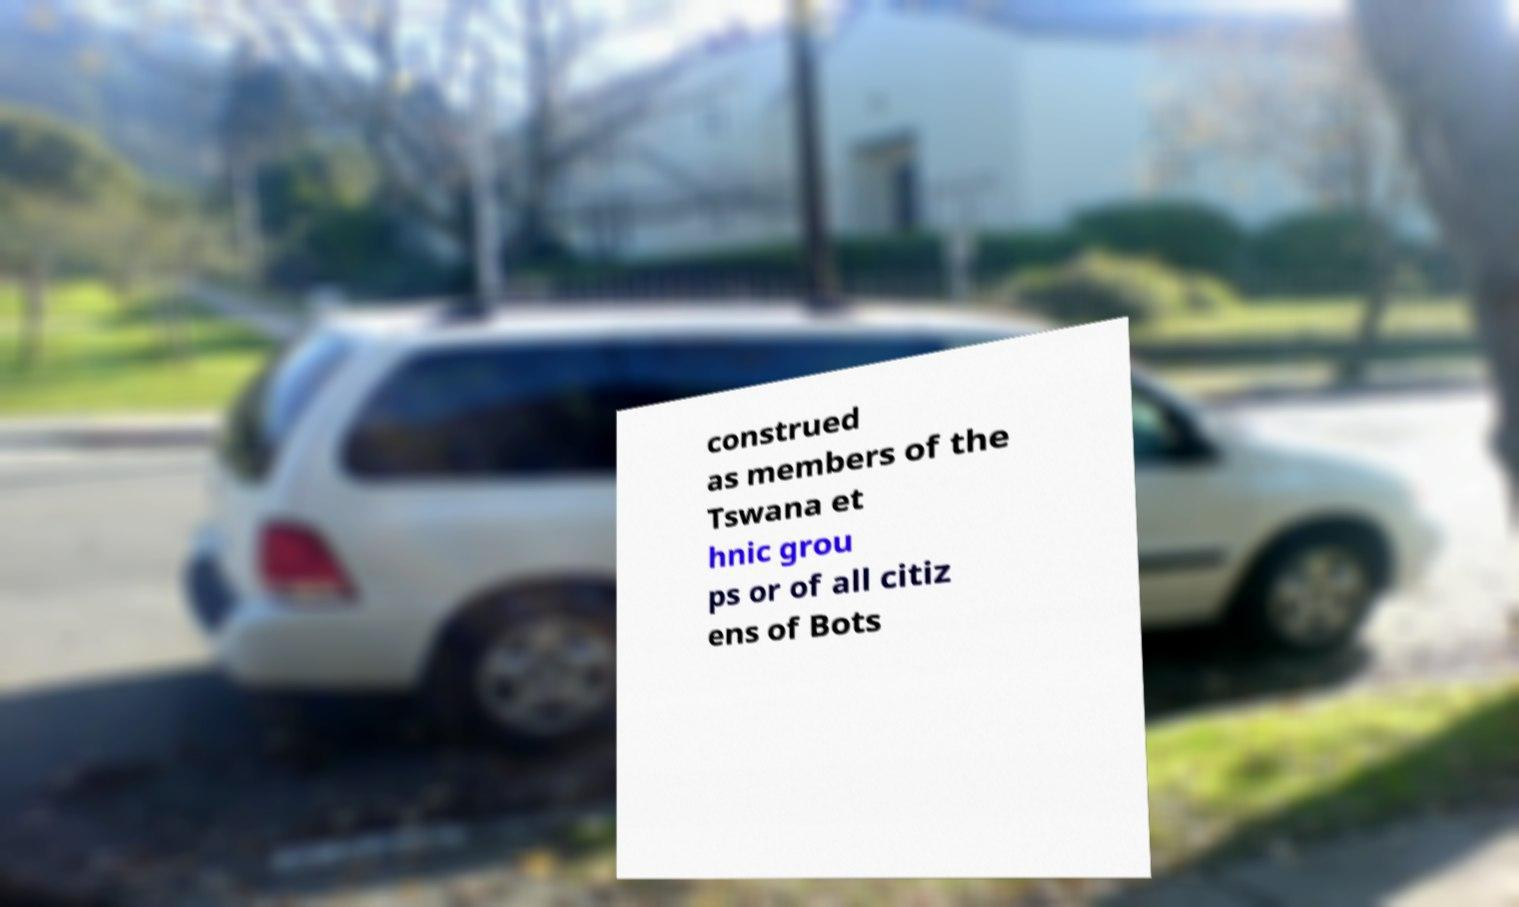I need the written content from this picture converted into text. Can you do that? construed as members of the Tswana et hnic grou ps or of all citiz ens of Bots 